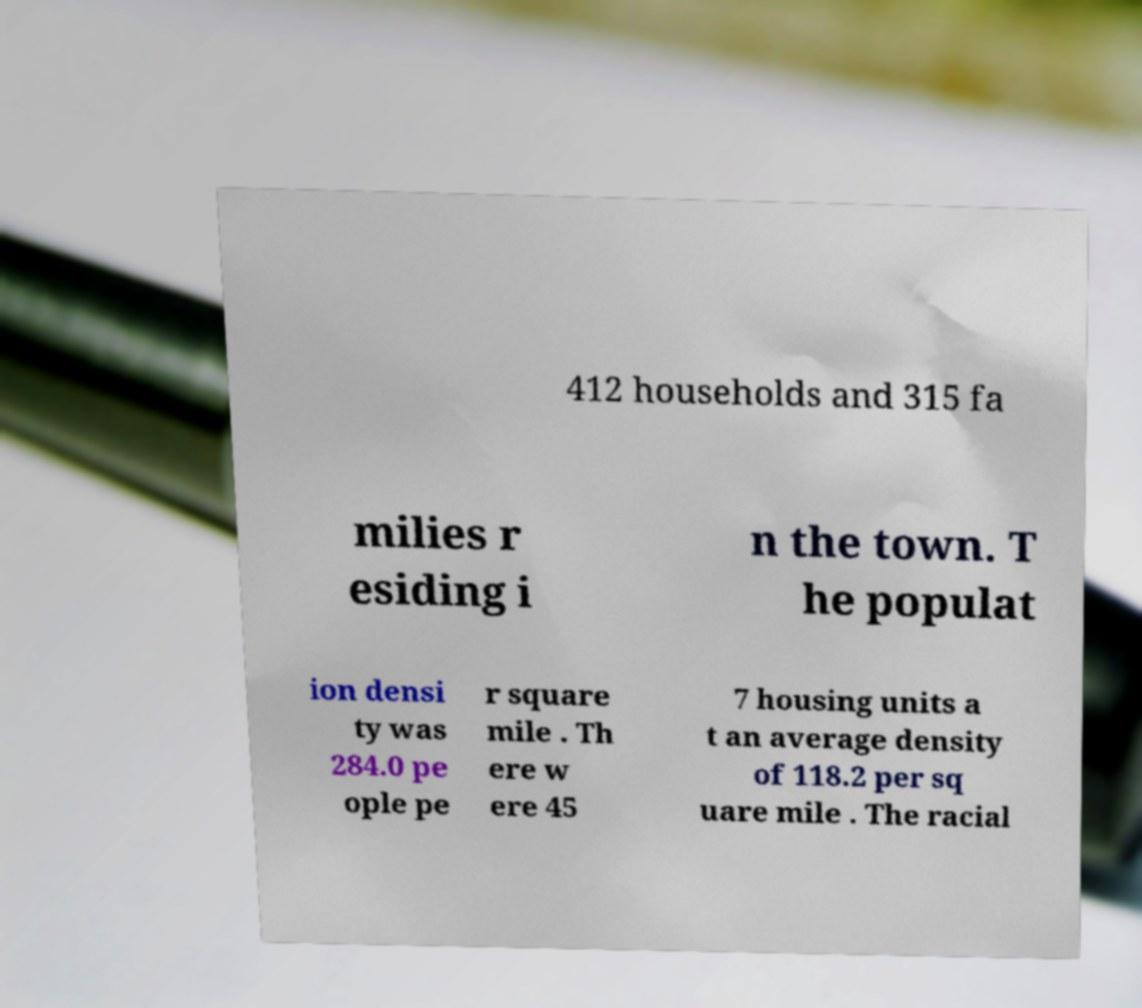Please identify and transcribe the text found in this image. 412 households and 315 fa milies r esiding i n the town. T he populat ion densi ty was 284.0 pe ople pe r square mile . Th ere w ere 45 7 housing units a t an average density of 118.2 per sq uare mile . The racial 